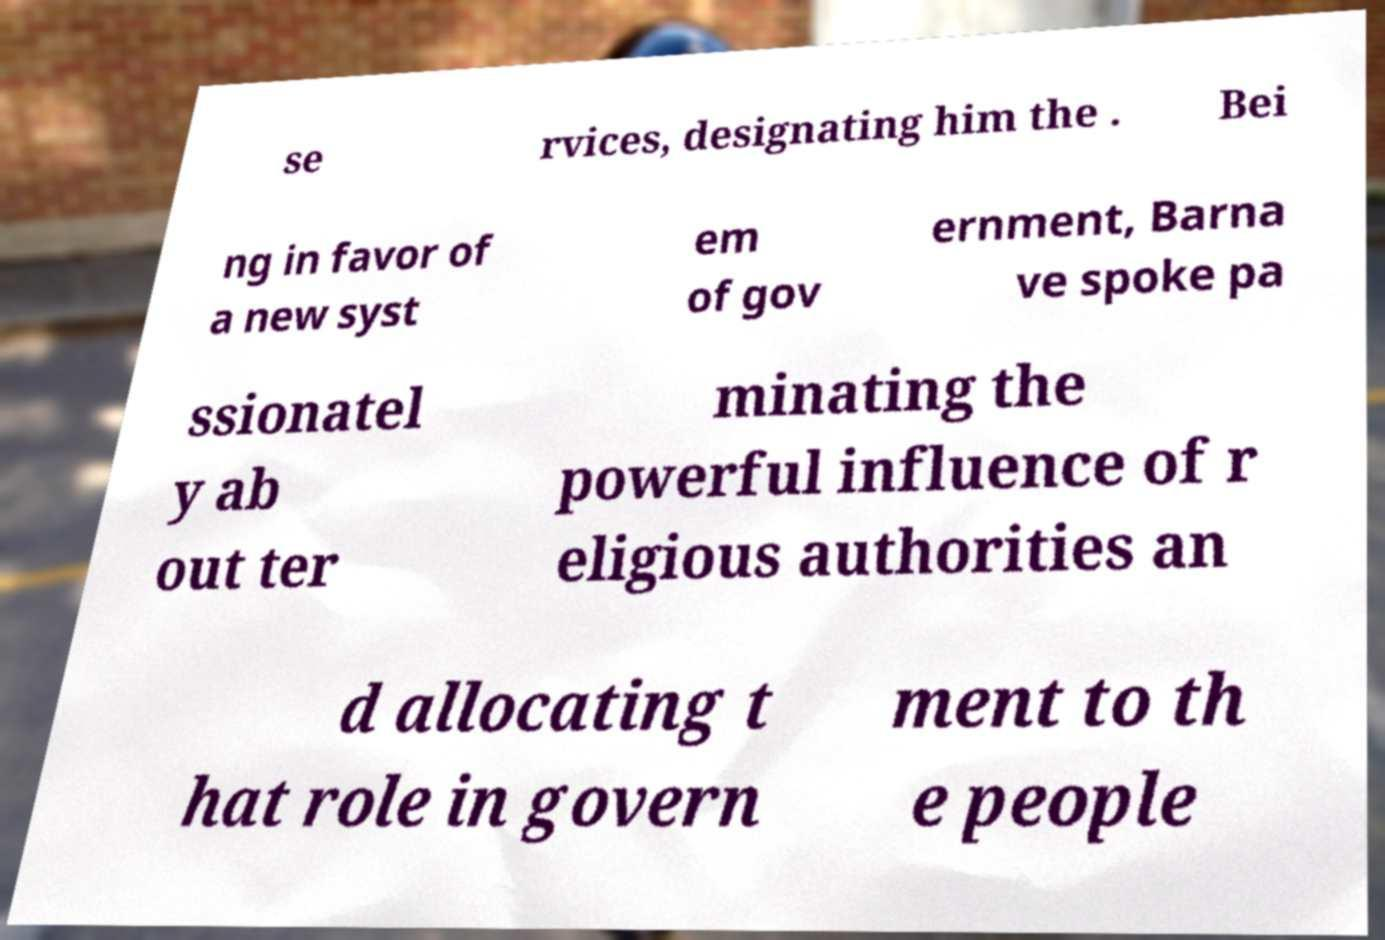Please identify and transcribe the text found in this image. se rvices, designating him the . Bei ng in favor of a new syst em of gov ernment, Barna ve spoke pa ssionatel y ab out ter minating the powerful influence of r eligious authorities an d allocating t hat role in govern ment to th e people 